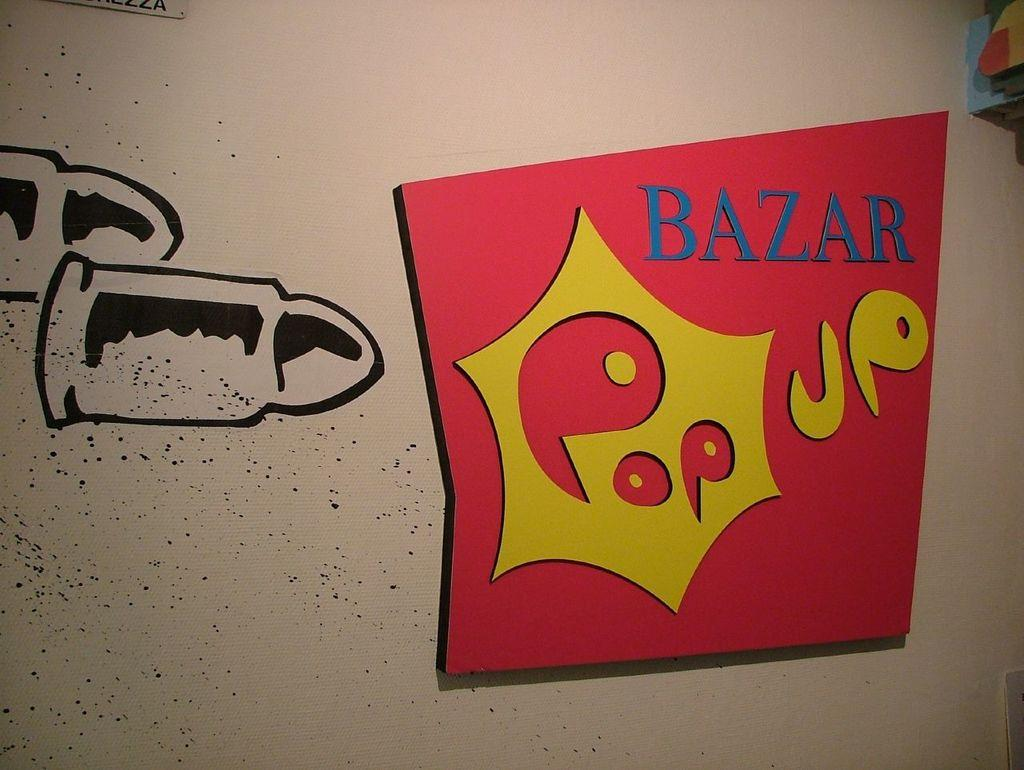<image>
Share a concise interpretation of the image provided. A sign with bullets and a colorful part that says bazar pop up. 